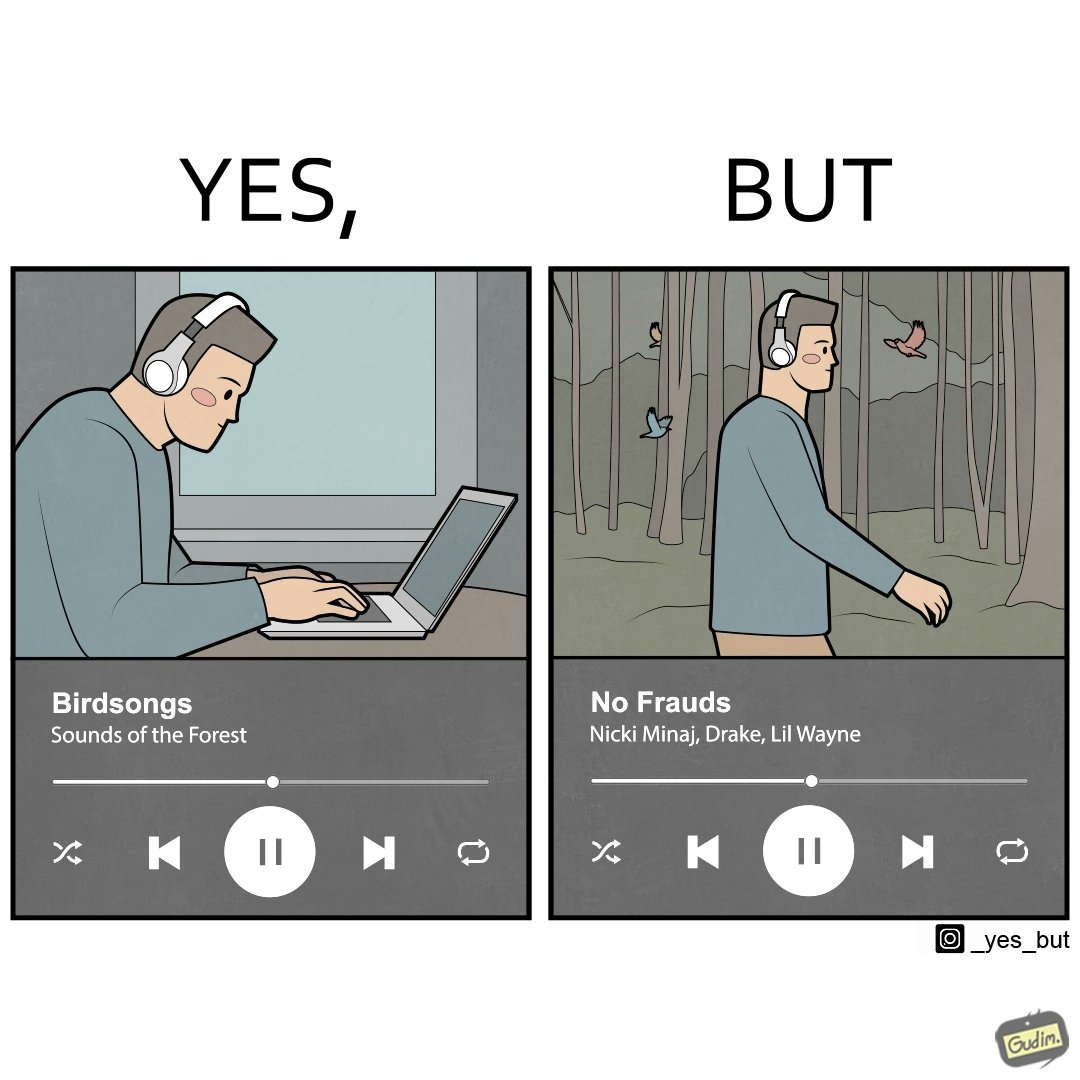Why is this image considered satirical? The image is ironic, because people nowadays at home want to feel the nature but when the same person gets some moments to enjoy the nature they just ignore the surroundings 